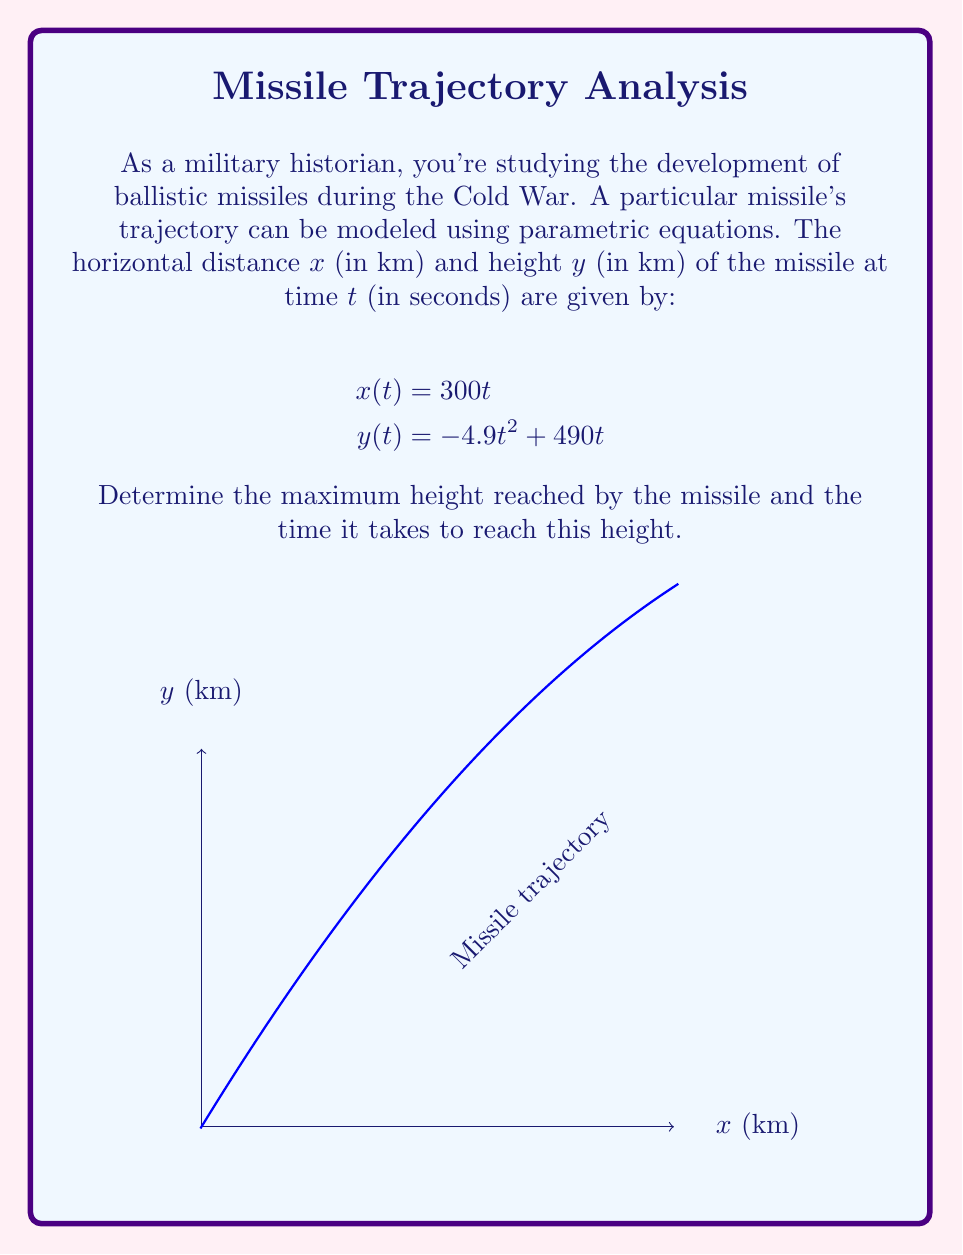Teach me how to tackle this problem. To solve this problem, we'll follow these steps:

1) The maximum height occurs when the vertical velocity is zero. We can find this by taking the derivative of $y(t)$ with respect to $t$ and setting it to zero.

2) $\frac{dy}{dt} = -9.8t + 490$

3) Set this equal to zero and solve for $t$:
   $-9.8t + 490 = 0$
   $-9.8t = -490$
   $t = 50$ seconds

4) Now that we know the time at which the maximum height occurs, we can plug this back into the original equation for $y(t)$ to find the maximum height:

   $y(50) = -4.9(50)^2 + 490(50)$
   $= -4.9(2500) + 24500$
   $= -12250 + 24500$
   $= 12250$ km

Therefore, the missile reaches its maximum height of 12,250 km at $t = 50$ seconds.
Answer: Maximum height: 12,250 km; Time to reach maximum height: 50 seconds 